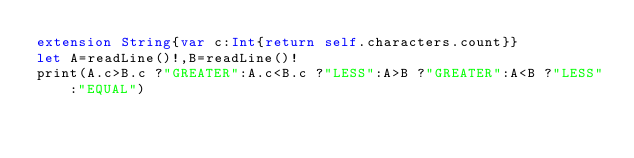Convert code to text. <code><loc_0><loc_0><loc_500><loc_500><_Swift_>extension String{var c:Int{return self.characters.count}}
let A=readLine()!,B=readLine()!
print(A.c>B.c ?"GREATER":A.c<B.c ?"LESS":A>B ?"GREATER":A<B ?"LESS":"EQUAL")</code> 